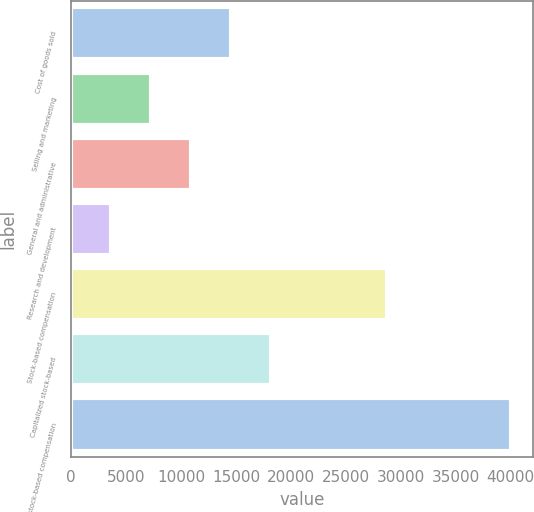<chart> <loc_0><loc_0><loc_500><loc_500><bar_chart><fcel>Cost of goods sold<fcel>Selling and marketing<fcel>General and administrative<fcel>Research and development<fcel>Stock-based compensation<fcel>Capitalized stock-based<fcel>Total stock-based compensation<nl><fcel>14550.3<fcel>7270.1<fcel>10910.2<fcel>3630<fcel>28765<fcel>18190.4<fcel>40031<nl></chart> 